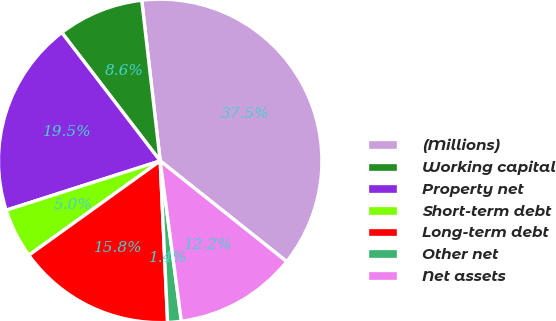Convert chart. <chart><loc_0><loc_0><loc_500><loc_500><pie_chart><fcel>(Millions)<fcel>Working capital<fcel>Property net<fcel>Short-term debt<fcel>Long-term debt<fcel>Other net<fcel>Net assets<nl><fcel>37.52%<fcel>8.59%<fcel>19.52%<fcel>4.98%<fcel>15.82%<fcel>1.36%<fcel>12.21%<nl></chart> 